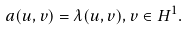<formula> <loc_0><loc_0><loc_500><loc_500>a ( u , v ) = \lambda ( u , v ) , v \in H ^ { 1 } .</formula> 